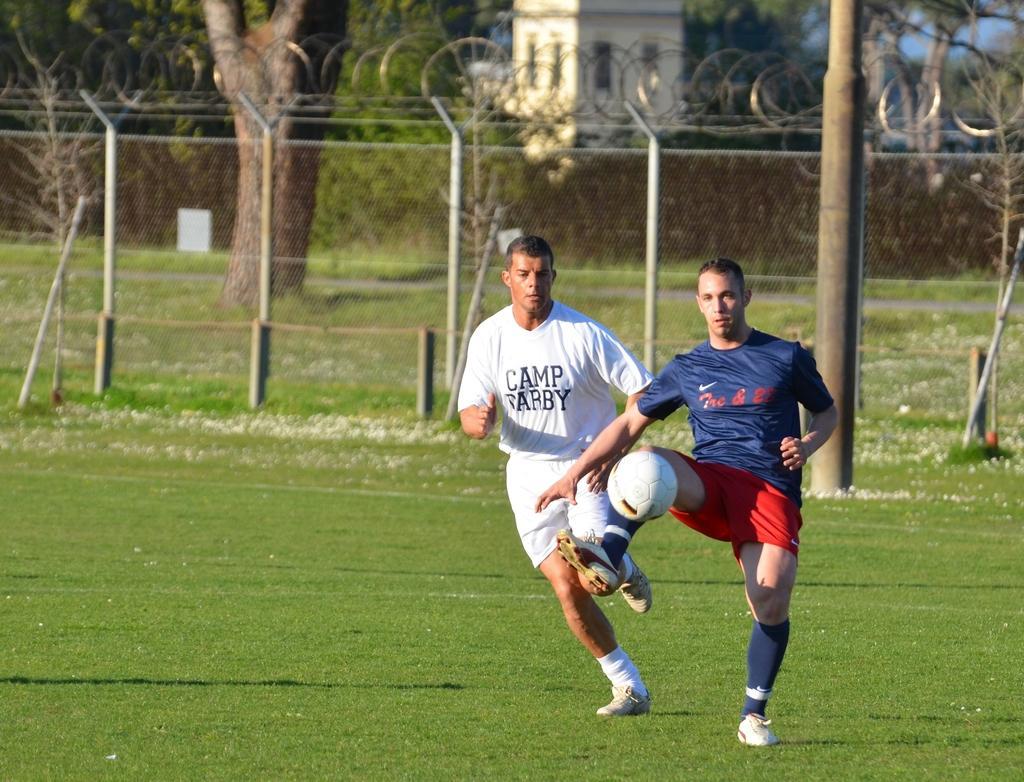Can you describe this image briefly? In this picture we can two players wearing blue color t-shirt and red shorts playing football in the grass ground. Behind we can see fencing grill. In the background we can see some tree and white color house. 